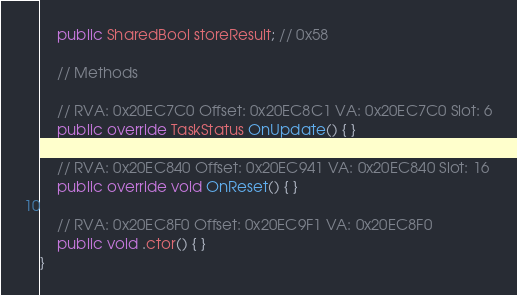Convert code to text. <code><loc_0><loc_0><loc_500><loc_500><_C#_>	public SharedBool storeResult; // 0x58

	// Methods

	// RVA: 0x20EC7C0 Offset: 0x20EC8C1 VA: 0x20EC7C0 Slot: 6
	public override TaskStatus OnUpdate() { }

	// RVA: 0x20EC840 Offset: 0x20EC941 VA: 0x20EC840 Slot: 16
	public override void OnReset() { }

	// RVA: 0x20EC8F0 Offset: 0x20EC9F1 VA: 0x20EC8F0
	public void .ctor() { }
}

</code> 